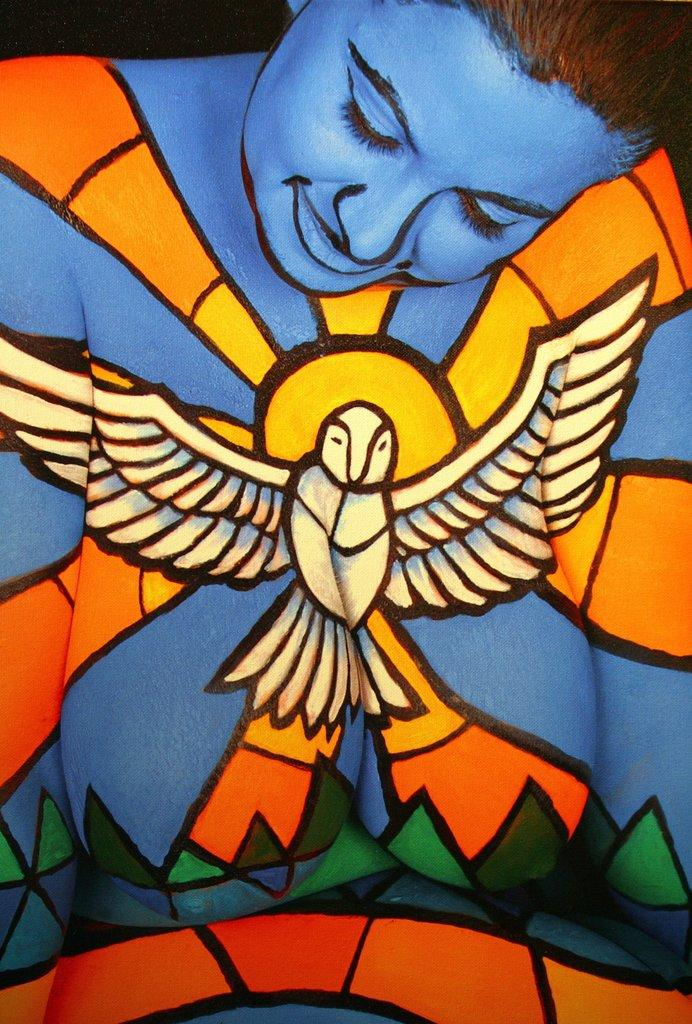What type of artwork is depicted in the image? The image is a painting. Who or what is the main subject of the painting? There is a woman in the painting. What is the woman wearing? The woman is wearing a dress. What is the woman's facial expression in the painting? The woman is smiling. How would you describe the background of the painting? The background of the painting is dark in color. What is the profit margin of the watch depicted in the painting? There is no watch present in the painting; it features a woman wearing a dress and smiling against a dark background. 